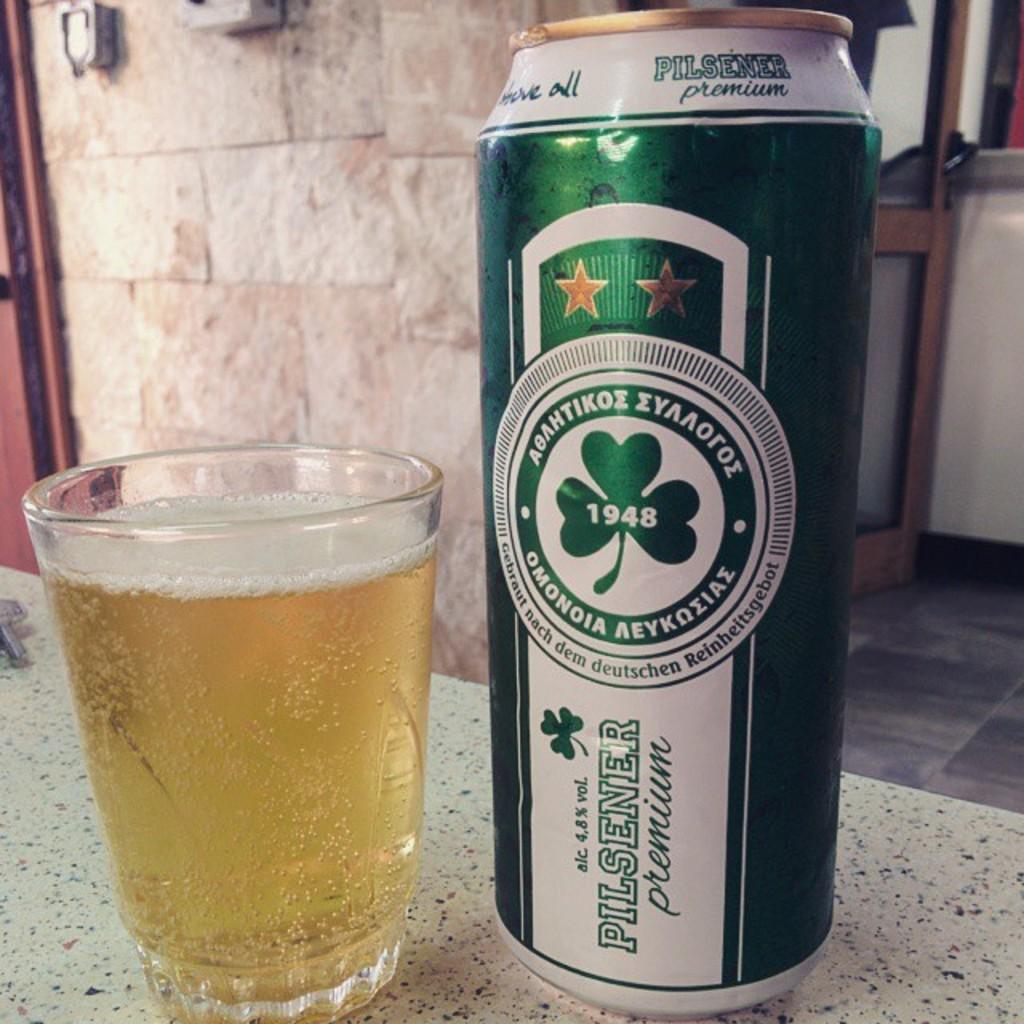What year was this beer brand likely first established in?
Provide a short and direct response. 1948. What is the brand of beer?
Make the answer very short. Pilsener. 